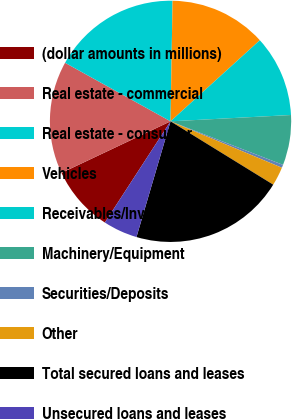Convert chart. <chart><loc_0><loc_0><loc_500><loc_500><pie_chart><fcel>(dollar amounts in millions)<fcel>Real estate - commercial<fcel>Real estate - consumer<fcel>Vehicles<fcel>Receivables/Inventory<fcel>Machinery/Equipment<fcel>Securities/Deposits<fcel>Other<fcel>Total secured loans and leases<fcel>Unsecured loans and leases<nl><fcel>8.8%<fcel>15.1%<fcel>17.2%<fcel>13.0%<fcel>10.9%<fcel>6.71%<fcel>0.41%<fcel>2.51%<fcel>20.76%<fcel>4.61%<nl></chart> 